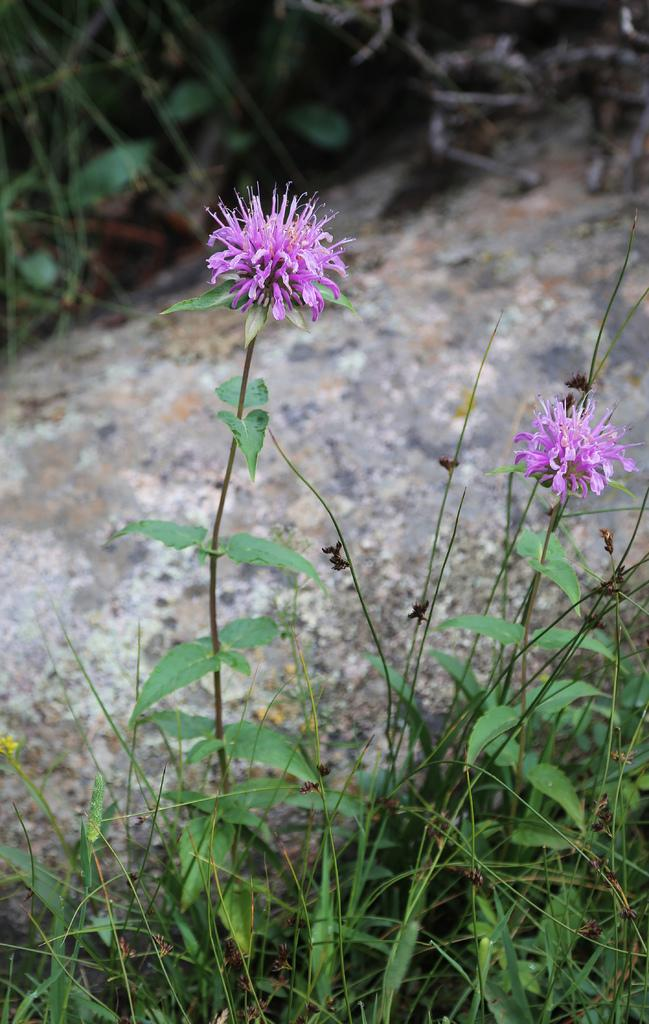How many flowers can be seen in the image? There are two flowers in the image. What color are the flowers? Both flowers are pink in color. What else can be seen in the image besides the flowers? There are plants present in the image. What type of prison can be seen in the image? There is no prison present in the image; it features two pink flowers and plants. How does the fork contribute to the growth of the flowers in the image? There is no fork present in the image, and therefore it cannot contribute to the growth of the flowers. 